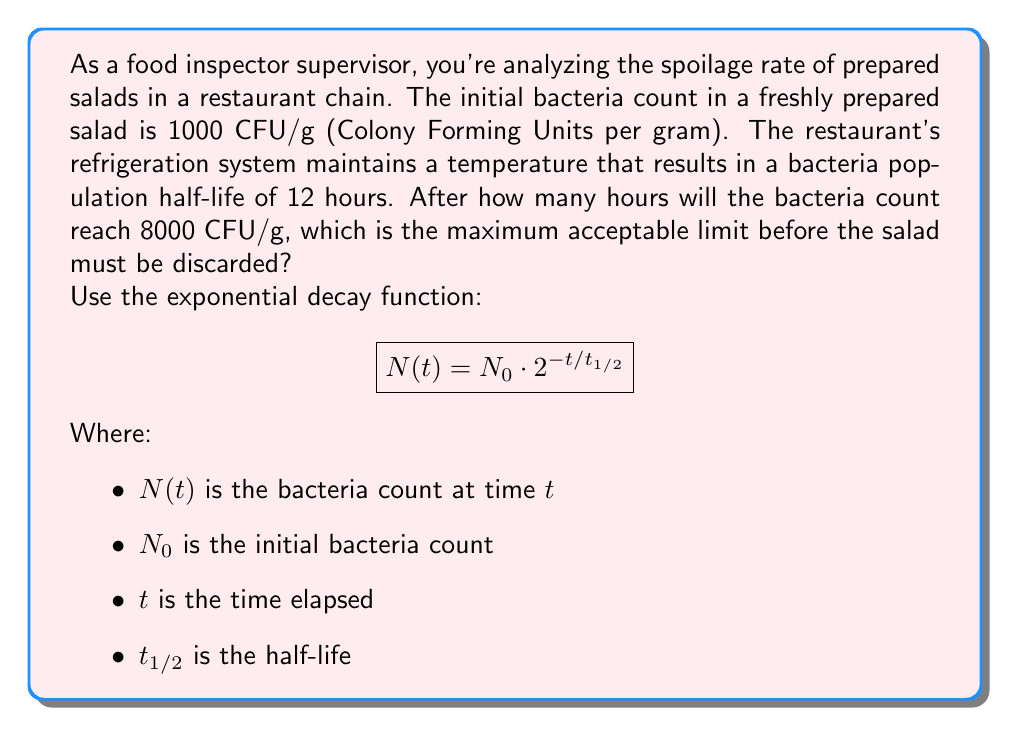Teach me how to tackle this problem. Let's approach this step-by-step:

1) We're given:
   $N_0 = 1000$ CFU/g (initial count)
   $t_{1/2} = 12$ hours (half-life)
   $N(t) = 8000$ CFU/g (target count)

2) We need to find $t$ when $N(t) = 8000$. Let's substitute these into the equation:

   $$8000 = 1000 \cdot 2^{-t/12}$$

3) Divide both sides by 1000:

   $$8 = 2^{-t/12}$$

4) Take the logarithm (base 2) of both sides:

   $$\log_2(8) = \log_2(2^{-t/12})$$

5) Simplify the left side and apply the logarithm property on the right:

   $$3 = -t/12$$

6) Multiply both sides by -12:

   $$-36 = t$$

7) Therefore, $t = 36$ hours.

This might seem counterintuitive because we're looking for growth, not decay. However, remember that exponential growth and decay are inverse processes. In this case, we're allowing the bacteria to grow until it reaches a certain threshold, which is equivalent to calculating how long it would take for the threshold amount to decay to the initial amount.
Answer: The bacteria count will reach 8000 CFU/g after 36 hours. 